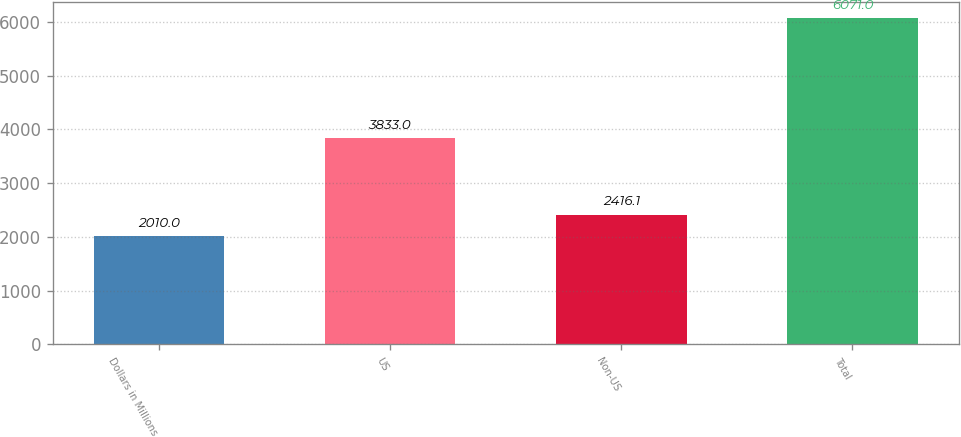Convert chart to OTSL. <chart><loc_0><loc_0><loc_500><loc_500><bar_chart><fcel>Dollars in Millions<fcel>US<fcel>Non-US<fcel>Total<nl><fcel>2010<fcel>3833<fcel>2416.1<fcel>6071<nl></chart> 